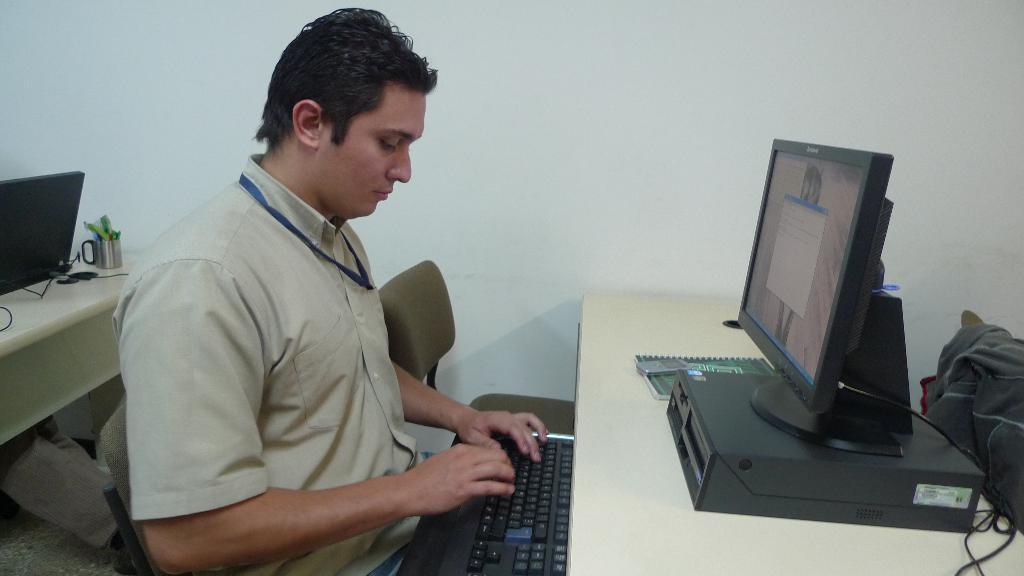How would you summarize this image in a sentence or two? A man is working with a desktop. 